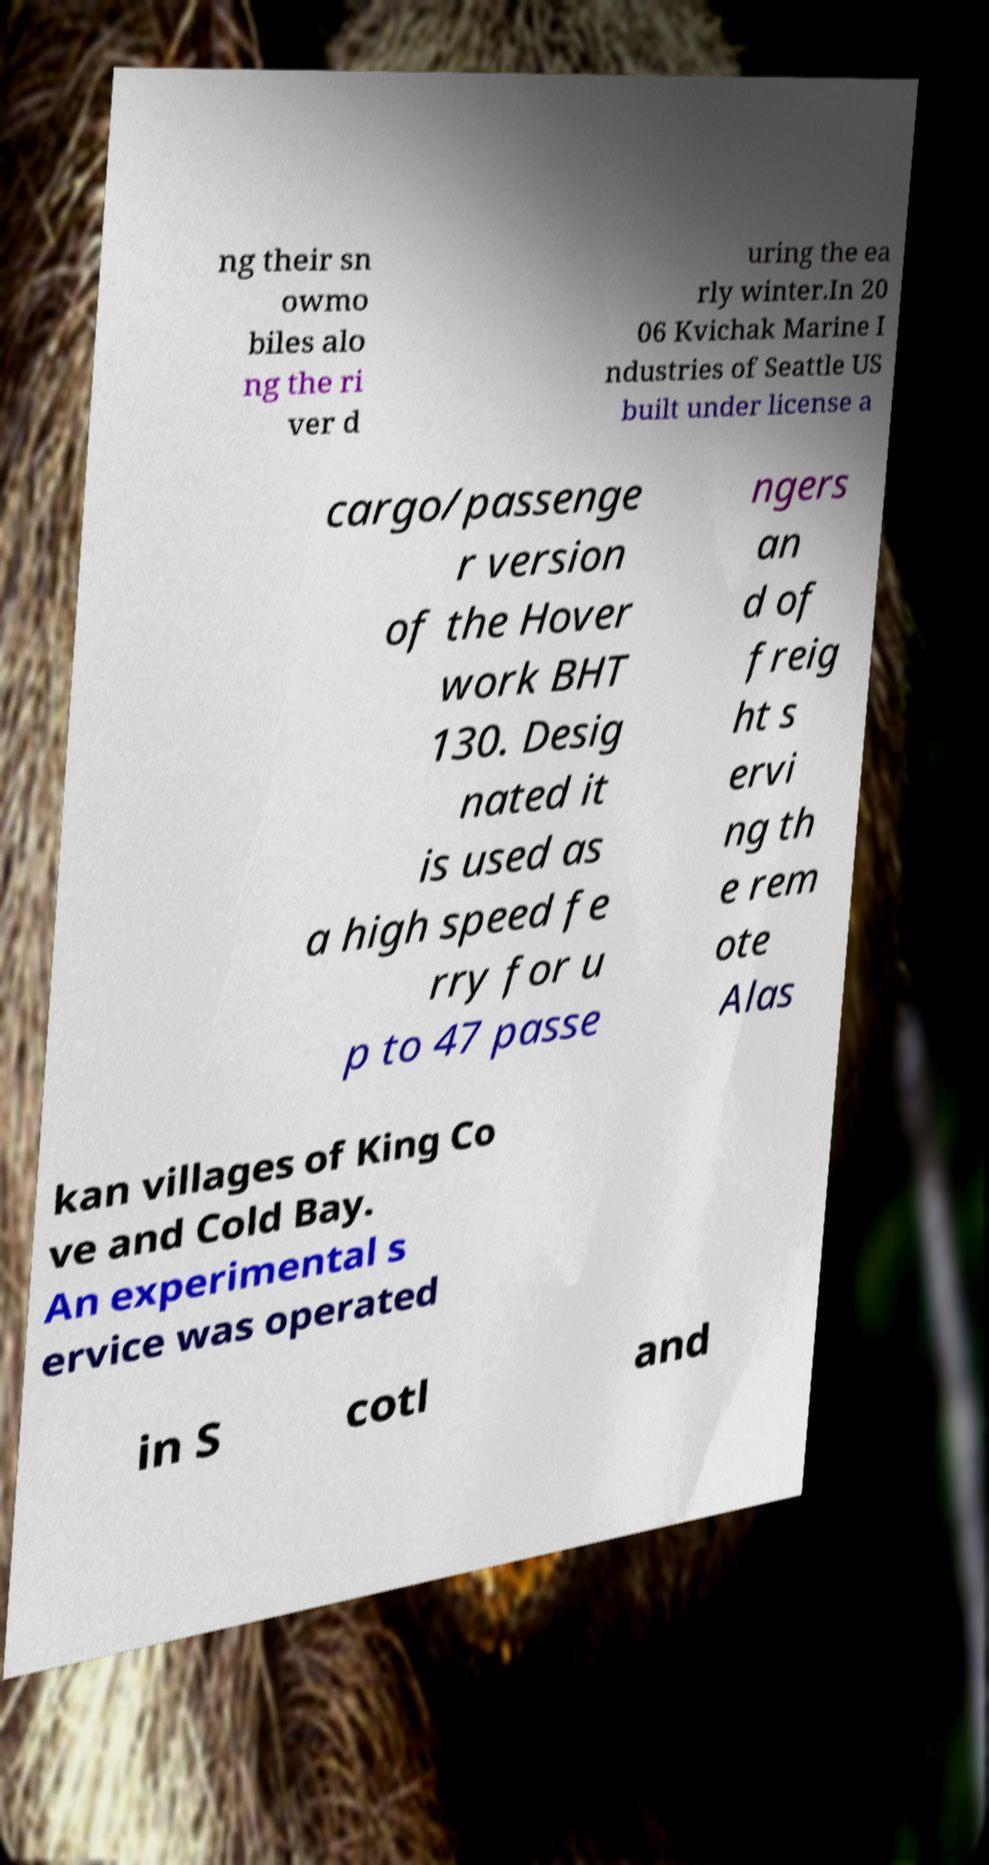I need the written content from this picture converted into text. Can you do that? ng their sn owmo biles alo ng the ri ver d uring the ea rly winter.In 20 06 Kvichak Marine I ndustries of Seattle US built under license a cargo/passenge r version of the Hover work BHT 130. Desig nated it is used as a high speed fe rry for u p to 47 passe ngers an d of freig ht s ervi ng th e rem ote Alas kan villages of King Co ve and Cold Bay. An experimental s ervice was operated in S cotl and 